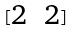<formula> <loc_0><loc_0><loc_500><loc_500>[ \begin{matrix} 2 & 2 \end{matrix} ]</formula> 